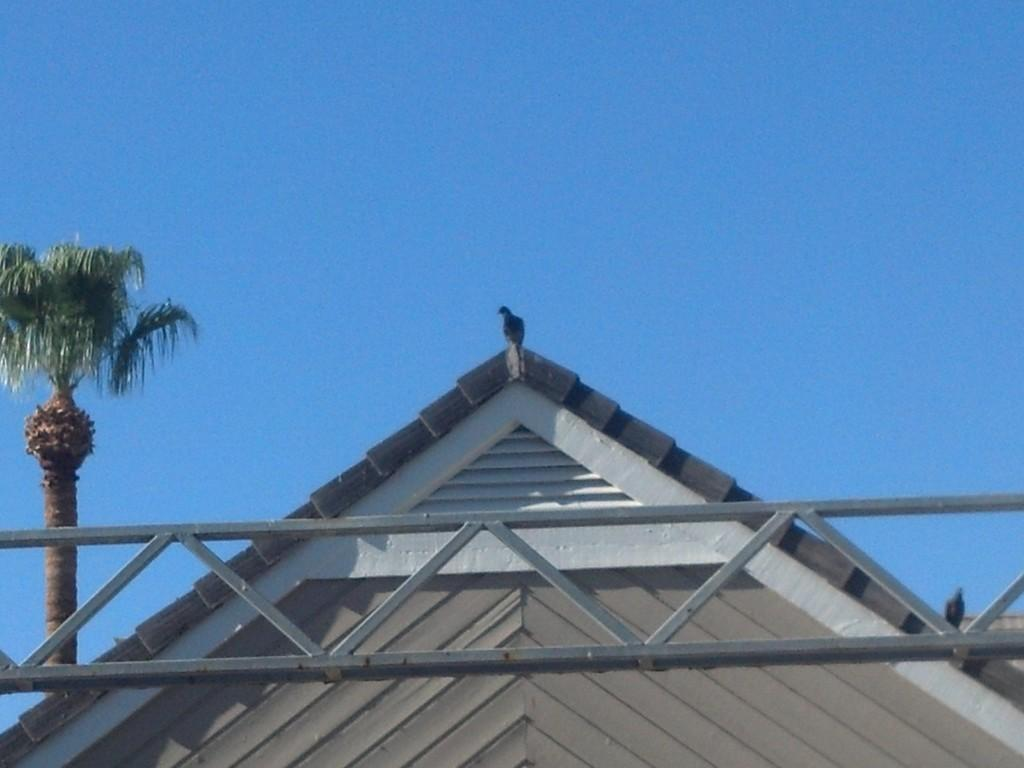What is on top of the building in the image? There is a bird on the roof of a building in the image. What type of structure can be seen in the image? There is a metal structure in the image. What type of tree is present in the image? There is a coconut tree in the image. What can be seen in the background of the image? The sky is visible in the background of the image. What color crayon is the bird holding in the image? There are no crayons present in the image, and the bird is not holding anything. 